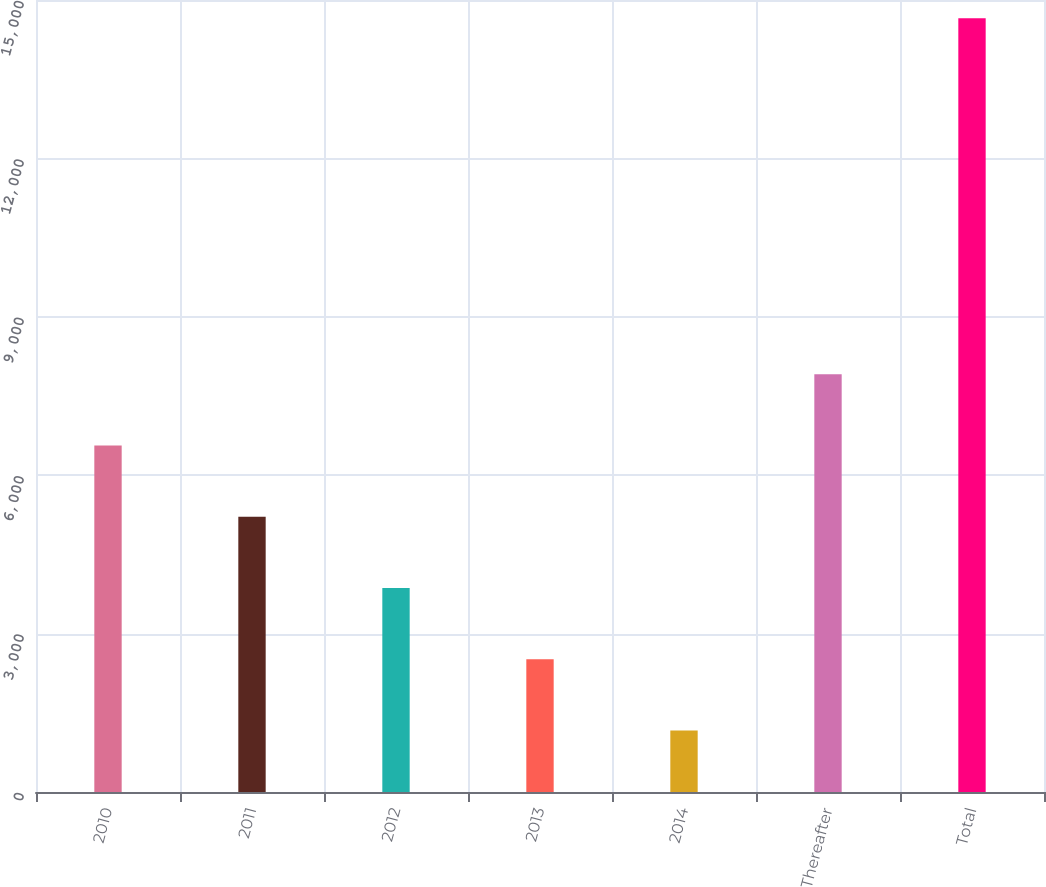Convert chart. <chart><loc_0><loc_0><loc_500><loc_500><bar_chart><fcel>2010<fcel>2011<fcel>2012<fcel>2013<fcel>2014<fcel>Thereafter<fcel>Total<nl><fcel>6562<fcel>5213<fcel>3864<fcel>2515<fcel>1166<fcel>7911<fcel>14656<nl></chart> 